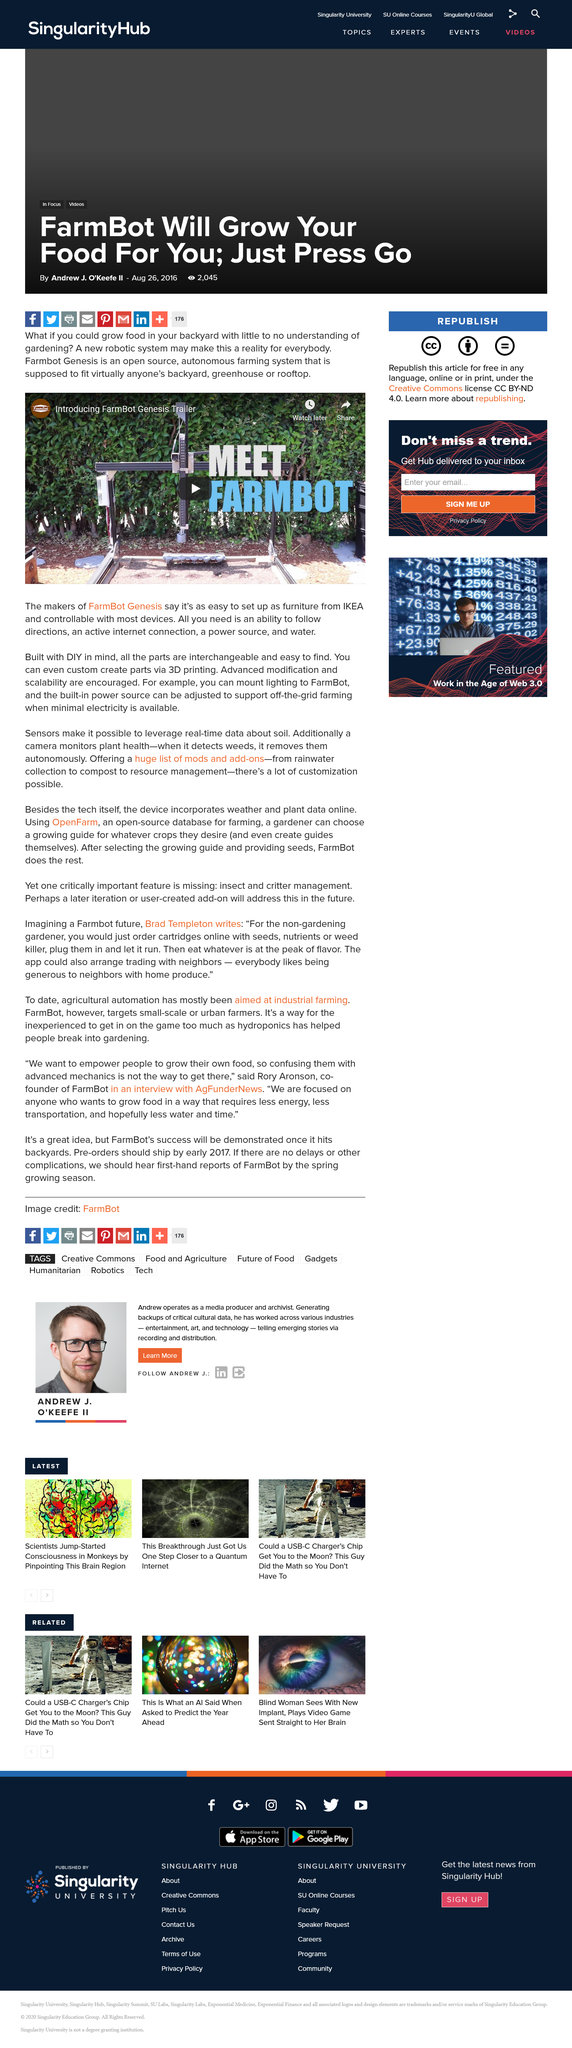Indicate a few pertinent items in this graphic. The purpose and design of the structure is evident, as it was clearly built with DIY principles in mind. 3D printing technology enables the creation of custom parts with precision and accuracy, making it a valuable tool for manufacturing and product development. The comparison of furniture stores is similar to IKEA furniture. 